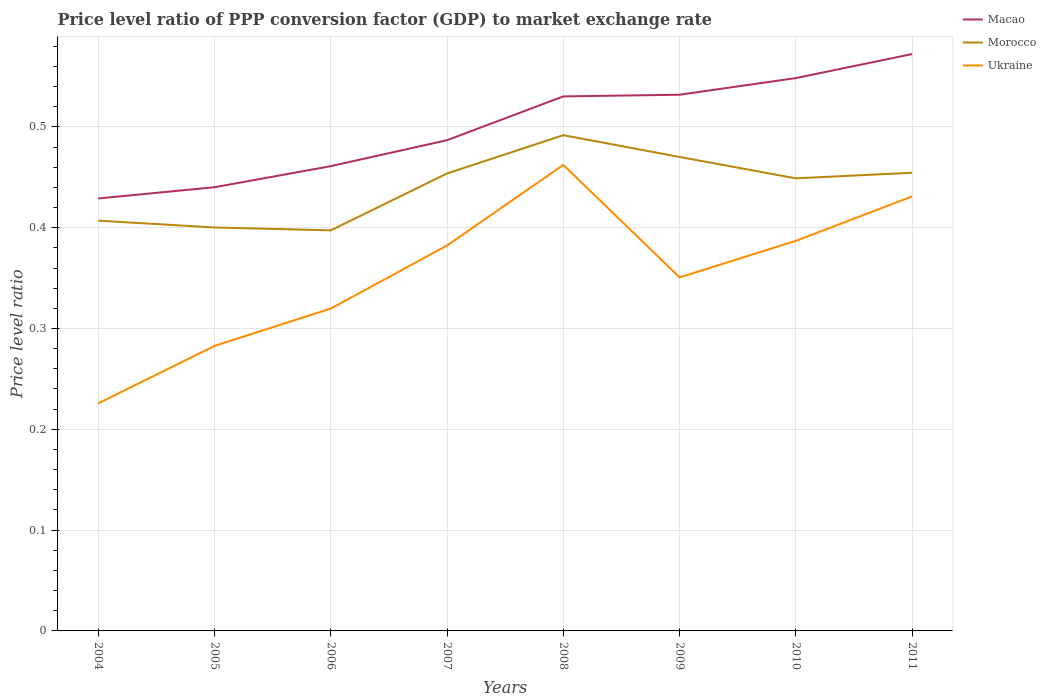How many different coloured lines are there?
Your answer should be very brief. 3. Does the line corresponding to Ukraine intersect with the line corresponding to Morocco?
Offer a very short reply. No. Across all years, what is the maximum price level ratio in Macao?
Give a very brief answer. 0.43. What is the total price level ratio in Morocco in the graph?
Give a very brief answer. -0.06. What is the difference between the highest and the second highest price level ratio in Macao?
Offer a very short reply. 0.14. Is the price level ratio in Ukraine strictly greater than the price level ratio in Morocco over the years?
Keep it short and to the point. Yes. How many lines are there?
Make the answer very short. 3. Does the graph contain any zero values?
Ensure brevity in your answer.  No. Does the graph contain grids?
Provide a short and direct response. Yes. How are the legend labels stacked?
Offer a terse response. Vertical. What is the title of the graph?
Ensure brevity in your answer.  Price level ratio of PPP conversion factor (GDP) to market exchange rate. What is the label or title of the X-axis?
Provide a short and direct response. Years. What is the label or title of the Y-axis?
Make the answer very short. Price level ratio. What is the Price level ratio in Macao in 2004?
Keep it short and to the point. 0.43. What is the Price level ratio in Morocco in 2004?
Your response must be concise. 0.41. What is the Price level ratio of Ukraine in 2004?
Provide a succinct answer. 0.23. What is the Price level ratio in Macao in 2005?
Offer a terse response. 0.44. What is the Price level ratio of Morocco in 2005?
Ensure brevity in your answer.  0.4. What is the Price level ratio of Ukraine in 2005?
Provide a succinct answer. 0.28. What is the Price level ratio in Macao in 2006?
Make the answer very short. 0.46. What is the Price level ratio of Morocco in 2006?
Provide a succinct answer. 0.4. What is the Price level ratio in Ukraine in 2006?
Give a very brief answer. 0.32. What is the Price level ratio in Macao in 2007?
Give a very brief answer. 0.49. What is the Price level ratio of Morocco in 2007?
Make the answer very short. 0.45. What is the Price level ratio in Ukraine in 2007?
Offer a very short reply. 0.38. What is the Price level ratio in Macao in 2008?
Give a very brief answer. 0.53. What is the Price level ratio of Morocco in 2008?
Your answer should be compact. 0.49. What is the Price level ratio of Ukraine in 2008?
Provide a short and direct response. 0.46. What is the Price level ratio in Macao in 2009?
Provide a succinct answer. 0.53. What is the Price level ratio of Morocco in 2009?
Provide a succinct answer. 0.47. What is the Price level ratio of Ukraine in 2009?
Make the answer very short. 0.35. What is the Price level ratio of Macao in 2010?
Your answer should be very brief. 0.55. What is the Price level ratio of Morocco in 2010?
Your answer should be compact. 0.45. What is the Price level ratio of Ukraine in 2010?
Your answer should be very brief. 0.39. What is the Price level ratio of Macao in 2011?
Your answer should be very brief. 0.57. What is the Price level ratio in Morocco in 2011?
Provide a succinct answer. 0.45. What is the Price level ratio of Ukraine in 2011?
Your answer should be compact. 0.43. Across all years, what is the maximum Price level ratio in Macao?
Give a very brief answer. 0.57. Across all years, what is the maximum Price level ratio in Morocco?
Provide a short and direct response. 0.49. Across all years, what is the maximum Price level ratio of Ukraine?
Make the answer very short. 0.46. Across all years, what is the minimum Price level ratio of Macao?
Your answer should be compact. 0.43. Across all years, what is the minimum Price level ratio of Morocco?
Give a very brief answer. 0.4. Across all years, what is the minimum Price level ratio of Ukraine?
Give a very brief answer. 0.23. What is the total Price level ratio of Macao in the graph?
Your answer should be compact. 4. What is the total Price level ratio of Morocco in the graph?
Offer a terse response. 3.52. What is the total Price level ratio of Ukraine in the graph?
Provide a succinct answer. 2.84. What is the difference between the Price level ratio in Macao in 2004 and that in 2005?
Your answer should be compact. -0.01. What is the difference between the Price level ratio in Morocco in 2004 and that in 2005?
Your response must be concise. 0.01. What is the difference between the Price level ratio in Ukraine in 2004 and that in 2005?
Offer a very short reply. -0.06. What is the difference between the Price level ratio in Macao in 2004 and that in 2006?
Ensure brevity in your answer.  -0.03. What is the difference between the Price level ratio of Morocco in 2004 and that in 2006?
Offer a terse response. 0.01. What is the difference between the Price level ratio in Ukraine in 2004 and that in 2006?
Make the answer very short. -0.09. What is the difference between the Price level ratio in Macao in 2004 and that in 2007?
Make the answer very short. -0.06. What is the difference between the Price level ratio in Morocco in 2004 and that in 2007?
Provide a short and direct response. -0.05. What is the difference between the Price level ratio of Ukraine in 2004 and that in 2007?
Your answer should be compact. -0.16. What is the difference between the Price level ratio in Macao in 2004 and that in 2008?
Offer a very short reply. -0.1. What is the difference between the Price level ratio of Morocco in 2004 and that in 2008?
Give a very brief answer. -0.08. What is the difference between the Price level ratio of Ukraine in 2004 and that in 2008?
Offer a terse response. -0.24. What is the difference between the Price level ratio of Macao in 2004 and that in 2009?
Give a very brief answer. -0.1. What is the difference between the Price level ratio of Morocco in 2004 and that in 2009?
Your answer should be very brief. -0.06. What is the difference between the Price level ratio of Ukraine in 2004 and that in 2009?
Keep it short and to the point. -0.12. What is the difference between the Price level ratio in Macao in 2004 and that in 2010?
Keep it short and to the point. -0.12. What is the difference between the Price level ratio of Morocco in 2004 and that in 2010?
Your answer should be very brief. -0.04. What is the difference between the Price level ratio in Ukraine in 2004 and that in 2010?
Provide a short and direct response. -0.16. What is the difference between the Price level ratio of Macao in 2004 and that in 2011?
Provide a short and direct response. -0.14. What is the difference between the Price level ratio of Morocco in 2004 and that in 2011?
Provide a succinct answer. -0.05. What is the difference between the Price level ratio of Ukraine in 2004 and that in 2011?
Provide a succinct answer. -0.21. What is the difference between the Price level ratio in Macao in 2005 and that in 2006?
Offer a terse response. -0.02. What is the difference between the Price level ratio of Morocco in 2005 and that in 2006?
Keep it short and to the point. 0. What is the difference between the Price level ratio in Ukraine in 2005 and that in 2006?
Make the answer very short. -0.04. What is the difference between the Price level ratio in Macao in 2005 and that in 2007?
Offer a terse response. -0.05. What is the difference between the Price level ratio of Morocco in 2005 and that in 2007?
Provide a short and direct response. -0.05. What is the difference between the Price level ratio in Ukraine in 2005 and that in 2007?
Provide a succinct answer. -0.1. What is the difference between the Price level ratio of Macao in 2005 and that in 2008?
Offer a terse response. -0.09. What is the difference between the Price level ratio of Morocco in 2005 and that in 2008?
Your answer should be compact. -0.09. What is the difference between the Price level ratio of Ukraine in 2005 and that in 2008?
Provide a short and direct response. -0.18. What is the difference between the Price level ratio of Macao in 2005 and that in 2009?
Provide a succinct answer. -0.09. What is the difference between the Price level ratio of Morocco in 2005 and that in 2009?
Your response must be concise. -0.07. What is the difference between the Price level ratio in Ukraine in 2005 and that in 2009?
Your answer should be compact. -0.07. What is the difference between the Price level ratio in Macao in 2005 and that in 2010?
Provide a short and direct response. -0.11. What is the difference between the Price level ratio of Morocco in 2005 and that in 2010?
Your answer should be very brief. -0.05. What is the difference between the Price level ratio of Ukraine in 2005 and that in 2010?
Give a very brief answer. -0.1. What is the difference between the Price level ratio of Macao in 2005 and that in 2011?
Offer a very short reply. -0.13. What is the difference between the Price level ratio in Morocco in 2005 and that in 2011?
Your answer should be compact. -0.05. What is the difference between the Price level ratio in Ukraine in 2005 and that in 2011?
Ensure brevity in your answer.  -0.15. What is the difference between the Price level ratio of Macao in 2006 and that in 2007?
Ensure brevity in your answer.  -0.03. What is the difference between the Price level ratio in Morocco in 2006 and that in 2007?
Ensure brevity in your answer.  -0.06. What is the difference between the Price level ratio of Ukraine in 2006 and that in 2007?
Provide a succinct answer. -0.06. What is the difference between the Price level ratio in Macao in 2006 and that in 2008?
Keep it short and to the point. -0.07. What is the difference between the Price level ratio of Morocco in 2006 and that in 2008?
Provide a short and direct response. -0.09. What is the difference between the Price level ratio of Ukraine in 2006 and that in 2008?
Offer a terse response. -0.14. What is the difference between the Price level ratio of Macao in 2006 and that in 2009?
Your answer should be compact. -0.07. What is the difference between the Price level ratio of Morocco in 2006 and that in 2009?
Offer a very short reply. -0.07. What is the difference between the Price level ratio in Ukraine in 2006 and that in 2009?
Keep it short and to the point. -0.03. What is the difference between the Price level ratio in Macao in 2006 and that in 2010?
Your answer should be very brief. -0.09. What is the difference between the Price level ratio in Morocco in 2006 and that in 2010?
Provide a succinct answer. -0.05. What is the difference between the Price level ratio of Ukraine in 2006 and that in 2010?
Ensure brevity in your answer.  -0.07. What is the difference between the Price level ratio of Macao in 2006 and that in 2011?
Provide a short and direct response. -0.11. What is the difference between the Price level ratio in Morocco in 2006 and that in 2011?
Your answer should be compact. -0.06. What is the difference between the Price level ratio of Ukraine in 2006 and that in 2011?
Offer a terse response. -0.11. What is the difference between the Price level ratio in Macao in 2007 and that in 2008?
Provide a short and direct response. -0.04. What is the difference between the Price level ratio in Morocco in 2007 and that in 2008?
Keep it short and to the point. -0.04. What is the difference between the Price level ratio of Ukraine in 2007 and that in 2008?
Make the answer very short. -0.08. What is the difference between the Price level ratio in Macao in 2007 and that in 2009?
Your answer should be compact. -0.05. What is the difference between the Price level ratio of Morocco in 2007 and that in 2009?
Your response must be concise. -0.02. What is the difference between the Price level ratio in Ukraine in 2007 and that in 2009?
Give a very brief answer. 0.03. What is the difference between the Price level ratio in Macao in 2007 and that in 2010?
Provide a short and direct response. -0.06. What is the difference between the Price level ratio in Morocco in 2007 and that in 2010?
Keep it short and to the point. 0. What is the difference between the Price level ratio of Ukraine in 2007 and that in 2010?
Ensure brevity in your answer.  -0. What is the difference between the Price level ratio of Macao in 2007 and that in 2011?
Provide a short and direct response. -0.09. What is the difference between the Price level ratio in Morocco in 2007 and that in 2011?
Offer a terse response. -0. What is the difference between the Price level ratio of Ukraine in 2007 and that in 2011?
Give a very brief answer. -0.05. What is the difference between the Price level ratio in Macao in 2008 and that in 2009?
Ensure brevity in your answer.  -0. What is the difference between the Price level ratio in Morocco in 2008 and that in 2009?
Give a very brief answer. 0.02. What is the difference between the Price level ratio in Ukraine in 2008 and that in 2009?
Your response must be concise. 0.11. What is the difference between the Price level ratio of Macao in 2008 and that in 2010?
Make the answer very short. -0.02. What is the difference between the Price level ratio of Morocco in 2008 and that in 2010?
Ensure brevity in your answer.  0.04. What is the difference between the Price level ratio of Ukraine in 2008 and that in 2010?
Give a very brief answer. 0.08. What is the difference between the Price level ratio in Macao in 2008 and that in 2011?
Your response must be concise. -0.04. What is the difference between the Price level ratio of Morocco in 2008 and that in 2011?
Offer a very short reply. 0.04. What is the difference between the Price level ratio in Ukraine in 2008 and that in 2011?
Offer a terse response. 0.03. What is the difference between the Price level ratio of Macao in 2009 and that in 2010?
Your response must be concise. -0.02. What is the difference between the Price level ratio of Morocco in 2009 and that in 2010?
Provide a short and direct response. 0.02. What is the difference between the Price level ratio of Ukraine in 2009 and that in 2010?
Make the answer very short. -0.04. What is the difference between the Price level ratio in Macao in 2009 and that in 2011?
Ensure brevity in your answer.  -0.04. What is the difference between the Price level ratio of Morocco in 2009 and that in 2011?
Make the answer very short. 0.02. What is the difference between the Price level ratio in Ukraine in 2009 and that in 2011?
Your response must be concise. -0.08. What is the difference between the Price level ratio of Macao in 2010 and that in 2011?
Provide a succinct answer. -0.02. What is the difference between the Price level ratio in Morocco in 2010 and that in 2011?
Your response must be concise. -0.01. What is the difference between the Price level ratio in Ukraine in 2010 and that in 2011?
Your answer should be very brief. -0.04. What is the difference between the Price level ratio in Macao in 2004 and the Price level ratio in Morocco in 2005?
Ensure brevity in your answer.  0.03. What is the difference between the Price level ratio of Macao in 2004 and the Price level ratio of Ukraine in 2005?
Ensure brevity in your answer.  0.15. What is the difference between the Price level ratio of Morocco in 2004 and the Price level ratio of Ukraine in 2005?
Provide a short and direct response. 0.12. What is the difference between the Price level ratio of Macao in 2004 and the Price level ratio of Morocco in 2006?
Your answer should be very brief. 0.03. What is the difference between the Price level ratio in Macao in 2004 and the Price level ratio in Ukraine in 2006?
Your answer should be compact. 0.11. What is the difference between the Price level ratio of Morocco in 2004 and the Price level ratio of Ukraine in 2006?
Provide a short and direct response. 0.09. What is the difference between the Price level ratio of Macao in 2004 and the Price level ratio of Morocco in 2007?
Provide a short and direct response. -0.02. What is the difference between the Price level ratio of Macao in 2004 and the Price level ratio of Ukraine in 2007?
Provide a short and direct response. 0.05. What is the difference between the Price level ratio in Morocco in 2004 and the Price level ratio in Ukraine in 2007?
Provide a succinct answer. 0.02. What is the difference between the Price level ratio of Macao in 2004 and the Price level ratio of Morocco in 2008?
Your answer should be compact. -0.06. What is the difference between the Price level ratio of Macao in 2004 and the Price level ratio of Ukraine in 2008?
Your response must be concise. -0.03. What is the difference between the Price level ratio of Morocco in 2004 and the Price level ratio of Ukraine in 2008?
Offer a very short reply. -0.06. What is the difference between the Price level ratio of Macao in 2004 and the Price level ratio of Morocco in 2009?
Provide a short and direct response. -0.04. What is the difference between the Price level ratio in Macao in 2004 and the Price level ratio in Ukraine in 2009?
Keep it short and to the point. 0.08. What is the difference between the Price level ratio in Morocco in 2004 and the Price level ratio in Ukraine in 2009?
Keep it short and to the point. 0.06. What is the difference between the Price level ratio in Macao in 2004 and the Price level ratio in Morocco in 2010?
Give a very brief answer. -0.02. What is the difference between the Price level ratio in Macao in 2004 and the Price level ratio in Ukraine in 2010?
Offer a very short reply. 0.04. What is the difference between the Price level ratio of Macao in 2004 and the Price level ratio of Morocco in 2011?
Your response must be concise. -0.03. What is the difference between the Price level ratio in Macao in 2004 and the Price level ratio in Ukraine in 2011?
Provide a short and direct response. -0. What is the difference between the Price level ratio of Morocco in 2004 and the Price level ratio of Ukraine in 2011?
Keep it short and to the point. -0.02. What is the difference between the Price level ratio in Macao in 2005 and the Price level ratio in Morocco in 2006?
Keep it short and to the point. 0.04. What is the difference between the Price level ratio of Macao in 2005 and the Price level ratio of Ukraine in 2006?
Offer a terse response. 0.12. What is the difference between the Price level ratio in Morocco in 2005 and the Price level ratio in Ukraine in 2006?
Make the answer very short. 0.08. What is the difference between the Price level ratio in Macao in 2005 and the Price level ratio in Morocco in 2007?
Provide a succinct answer. -0.01. What is the difference between the Price level ratio of Macao in 2005 and the Price level ratio of Ukraine in 2007?
Ensure brevity in your answer.  0.06. What is the difference between the Price level ratio in Morocco in 2005 and the Price level ratio in Ukraine in 2007?
Your answer should be compact. 0.02. What is the difference between the Price level ratio in Macao in 2005 and the Price level ratio in Morocco in 2008?
Provide a short and direct response. -0.05. What is the difference between the Price level ratio in Macao in 2005 and the Price level ratio in Ukraine in 2008?
Make the answer very short. -0.02. What is the difference between the Price level ratio in Morocco in 2005 and the Price level ratio in Ukraine in 2008?
Provide a short and direct response. -0.06. What is the difference between the Price level ratio in Macao in 2005 and the Price level ratio in Morocco in 2009?
Keep it short and to the point. -0.03. What is the difference between the Price level ratio in Macao in 2005 and the Price level ratio in Ukraine in 2009?
Provide a succinct answer. 0.09. What is the difference between the Price level ratio of Morocco in 2005 and the Price level ratio of Ukraine in 2009?
Make the answer very short. 0.05. What is the difference between the Price level ratio in Macao in 2005 and the Price level ratio in Morocco in 2010?
Your answer should be compact. -0.01. What is the difference between the Price level ratio in Macao in 2005 and the Price level ratio in Ukraine in 2010?
Provide a succinct answer. 0.05. What is the difference between the Price level ratio in Morocco in 2005 and the Price level ratio in Ukraine in 2010?
Give a very brief answer. 0.01. What is the difference between the Price level ratio of Macao in 2005 and the Price level ratio of Morocco in 2011?
Your answer should be compact. -0.01. What is the difference between the Price level ratio of Macao in 2005 and the Price level ratio of Ukraine in 2011?
Offer a very short reply. 0.01. What is the difference between the Price level ratio in Morocco in 2005 and the Price level ratio in Ukraine in 2011?
Ensure brevity in your answer.  -0.03. What is the difference between the Price level ratio in Macao in 2006 and the Price level ratio in Morocco in 2007?
Offer a terse response. 0.01. What is the difference between the Price level ratio of Macao in 2006 and the Price level ratio of Ukraine in 2007?
Ensure brevity in your answer.  0.08. What is the difference between the Price level ratio of Morocco in 2006 and the Price level ratio of Ukraine in 2007?
Offer a terse response. 0.01. What is the difference between the Price level ratio in Macao in 2006 and the Price level ratio in Morocco in 2008?
Ensure brevity in your answer.  -0.03. What is the difference between the Price level ratio in Macao in 2006 and the Price level ratio in Ukraine in 2008?
Your answer should be very brief. -0. What is the difference between the Price level ratio in Morocco in 2006 and the Price level ratio in Ukraine in 2008?
Ensure brevity in your answer.  -0.06. What is the difference between the Price level ratio in Macao in 2006 and the Price level ratio in Morocco in 2009?
Make the answer very short. -0.01. What is the difference between the Price level ratio in Macao in 2006 and the Price level ratio in Ukraine in 2009?
Your response must be concise. 0.11. What is the difference between the Price level ratio of Morocco in 2006 and the Price level ratio of Ukraine in 2009?
Make the answer very short. 0.05. What is the difference between the Price level ratio in Macao in 2006 and the Price level ratio in Morocco in 2010?
Your response must be concise. 0.01. What is the difference between the Price level ratio of Macao in 2006 and the Price level ratio of Ukraine in 2010?
Your answer should be very brief. 0.07. What is the difference between the Price level ratio in Morocco in 2006 and the Price level ratio in Ukraine in 2010?
Your answer should be compact. 0.01. What is the difference between the Price level ratio in Macao in 2006 and the Price level ratio in Morocco in 2011?
Give a very brief answer. 0.01. What is the difference between the Price level ratio in Macao in 2006 and the Price level ratio in Ukraine in 2011?
Give a very brief answer. 0.03. What is the difference between the Price level ratio of Morocco in 2006 and the Price level ratio of Ukraine in 2011?
Provide a short and direct response. -0.03. What is the difference between the Price level ratio of Macao in 2007 and the Price level ratio of Morocco in 2008?
Your answer should be very brief. -0.01. What is the difference between the Price level ratio of Macao in 2007 and the Price level ratio of Ukraine in 2008?
Ensure brevity in your answer.  0.02. What is the difference between the Price level ratio of Morocco in 2007 and the Price level ratio of Ukraine in 2008?
Make the answer very short. -0.01. What is the difference between the Price level ratio in Macao in 2007 and the Price level ratio in Morocco in 2009?
Make the answer very short. 0.02. What is the difference between the Price level ratio of Macao in 2007 and the Price level ratio of Ukraine in 2009?
Provide a succinct answer. 0.14. What is the difference between the Price level ratio of Morocco in 2007 and the Price level ratio of Ukraine in 2009?
Your answer should be very brief. 0.1. What is the difference between the Price level ratio in Macao in 2007 and the Price level ratio in Morocco in 2010?
Provide a succinct answer. 0.04. What is the difference between the Price level ratio of Macao in 2007 and the Price level ratio of Ukraine in 2010?
Provide a short and direct response. 0.1. What is the difference between the Price level ratio in Morocco in 2007 and the Price level ratio in Ukraine in 2010?
Give a very brief answer. 0.07. What is the difference between the Price level ratio in Macao in 2007 and the Price level ratio in Morocco in 2011?
Provide a succinct answer. 0.03. What is the difference between the Price level ratio in Macao in 2007 and the Price level ratio in Ukraine in 2011?
Ensure brevity in your answer.  0.06. What is the difference between the Price level ratio in Morocco in 2007 and the Price level ratio in Ukraine in 2011?
Your answer should be compact. 0.02. What is the difference between the Price level ratio of Macao in 2008 and the Price level ratio of Morocco in 2009?
Keep it short and to the point. 0.06. What is the difference between the Price level ratio of Macao in 2008 and the Price level ratio of Ukraine in 2009?
Offer a terse response. 0.18. What is the difference between the Price level ratio of Morocco in 2008 and the Price level ratio of Ukraine in 2009?
Provide a short and direct response. 0.14. What is the difference between the Price level ratio of Macao in 2008 and the Price level ratio of Morocco in 2010?
Your response must be concise. 0.08. What is the difference between the Price level ratio of Macao in 2008 and the Price level ratio of Ukraine in 2010?
Provide a succinct answer. 0.14. What is the difference between the Price level ratio in Morocco in 2008 and the Price level ratio in Ukraine in 2010?
Keep it short and to the point. 0.1. What is the difference between the Price level ratio of Macao in 2008 and the Price level ratio of Morocco in 2011?
Provide a short and direct response. 0.08. What is the difference between the Price level ratio of Macao in 2008 and the Price level ratio of Ukraine in 2011?
Offer a very short reply. 0.1. What is the difference between the Price level ratio in Morocco in 2008 and the Price level ratio in Ukraine in 2011?
Your answer should be compact. 0.06. What is the difference between the Price level ratio in Macao in 2009 and the Price level ratio in Morocco in 2010?
Your answer should be very brief. 0.08. What is the difference between the Price level ratio in Macao in 2009 and the Price level ratio in Ukraine in 2010?
Give a very brief answer. 0.14. What is the difference between the Price level ratio of Morocco in 2009 and the Price level ratio of Ukraine in 2010?
Your response must be concise. 0.08. What is the difference between the Price level ratio in Macao in 2009 and the Price level ratio in Morocco in 2011?
Give a very brief answer. 0.08. What is the difference between the Price level ratio in Macao in 2009 and the Price level ratio in Ukraine in 2011?
Your answer should be very brief. 0.1. What is the difference between the Price level ratio of Morocco in 2009 and the Price level ratio of Ukraine in 2011?
Provide a short and direct response. 0.04. What is the difference between the Price level ratio of Macao in 2010 and the Price level ratio of Morocco in 2011?
Your answer should be compact. 0.09. What is the difference between the Price level ratio in Macao in 2010 and the Price level ratio in Ukraine in 2011?
Provide a succinct answer. 0.12. What is the difference between the Price level ratio of Morocco in 2010 and the Price level ratio of Ukraine in 2011?
Keep it short and to the point. 0.02. What is the average Price level ratio of Morocco per year?
Provide a short and direct response. 0.44. What is the average Price level ratio of Ukraine per year?
Make the answer very short. 0.36. In the year 2004, what is the difference between the Price level ratio in Macao and Price level ratio in Morocco?
Your response must be concise. 0.02. In the year 2004, what is the difference between the Price level ratio of Macao and Price level ratio of Ukraine?
Provide a short and direct response. 0.2. In the year 2004, what is the difference between the Price level ratio in Morocco and Price level ratio in Ukraine?
Offer a terse response. 0.18. In the year 2005, what is the difference between the Price level ratio in Macao and Price level ratio in Morocco?
Make the answer very short. 0.04. In the year 2005, what is the difference between the Price level ratio in Macao and Price level ratio in Ukraine?
Keep it short and to the point. 0.16. In the year 2005, what is the difference between the Price level ratio of Morocco and Price level ratio of Ukraine?
Offer a very short reply. 0.12. In the year 2006, what is the difference between the Price level ratio of Macao and Price level ratio of Morocco?
Ensure brevity in your answer.  0.06. In the year 2006, what is the difference between the Price level ratio in Macao and Price level ratio in Ukraine?
Ensure brevity in your answer.  0.14. In the year 2006, what is the difference between the Price level ratio in Morocco and Price level ratio in Ukraine?
Provide a short and direct response. 0.08. In the year 2007, what is the difference between the Price level ratio of Macao and Price level ratio of Morocco?
Your answer should be compact. 0.03. In the year 2007, what is the difference between the Price level ratio of Macao and Price level ratio of Ukraine?
Give a very brief answer. 0.1. In the year 2007, what is the difference between the Price level ratio in Morocco and Price level ratio in Ukraine?
Provide a short and direct response. 0.07. In the year 2008, what is the difference between the Price level ratio in Macao and Price level ratio in Morocco?
Ensure brevity in your answer.  0.04. In the year 2008, what is the difference between the Price level ratio of Macao and Price level ratio of Ukraine?
Offer a very short reply. 0.07. In the year 2008, what is the difference between the Price level ratio of Morocco and Price level ratio of Ukraine?
Keep it short and to the point. 0.03. In the year 2009, what is the difference between the Price level ratio in Macao and Price level ratio in Morocco?
Your response must be concise. 0.06. In the year 2009, what is the difference between the Price level ratio of Macao and Price level ratio of Ukraine?
Ensure brevity in your answer.  0.18. In the year 2009, what is the difference between the Price level ratio in Morocco and Price level ratio in Ukraine?
Your answer should be very brief. 0.12. In the year 2010, what is the difference between the Price level ratio in Macao and Price level ratio in Morocco?
Make the answer very short. 0.1. In the year 2010, what is the difference between the Price level ratio in Macao and Price level ratio in Ukraine?
Provide a short and direct response. 0.16. In the year 2010, what is the difference between the Price level ratio of Morocco and Price level ratio of Ukraine?
Make the answer very short. 0.06. In the year 2011, what is the difference between the Price level ratio in Macao and Price level ratio in Morocco?
Your answer should be compact. 0.12. In the year 2011, what is the difference between the Price level ratio of Macao and Price level ratio of Ukraine?
Your response must be concise. 0.14. In the year 2011, what is the difference between the Price level ratio in Morocco and Price level ratio in Ukraine?
Make the answer very short. 0.02. What is the ratio of the Price level ratio in Macao in 2004 to that in 2005?
Your response must be concise. 0.97. What is the ratio of the Price level ratio of Morocco in 2004 to that in 2005?
Give a very brief answer. 1.02. What is the ratio of the Price level ratio in Ukraine in 2004 to that in 2005?
Provide a succinct answer. 0.8. What is the ratio of the Price level ratio of Macao in 2004 to that in 2006?
Provide a short and direct response. 0.93. What is the ratio of the Price level ratio of Morocco in 2004 to that in 2006?
Provide a succinct answer. 1.02. What is the ratio of the Price level ratio in Ukraine in 2004 to that in 2006?
Offer a very short reply. 0.71. What is the ratio of the Price level ratio in Macao in 2004 to that in 2007?
Make the answer very short. 0.88. What is the ratio of the Price level ratio of Morocco in 2004 to that in 2007?
Make the answer very short. 0.9. What is the ratio of the Price level ratio of Ukraine in 2004 to that in 2007?
Your response must be concise. 0.59. What is the ratio of the Price level ratio in Macao in 2004 to that in 2008?
Keep it short and to the point. 0.81. What is the ratio of the Price level ratio in Morocco in 2004 to that in 2008?
Give a very brief answer. 0.83. What is the ratio of the Price level ratio in Ukraine in 2004 to that in 2008?
Offer a terse response. 0.49. What is the ratio of the Price level ratio of Macao in 2004 to that in 2009?
Make the answer very short. 0.81. What is the ratio of the Price level ratio of Morocco in 2004 to that in 2009?
Provide a succinct answer. 0.87. What is the ratio of the Price level ratio of Ukraine in 2004 to that in 2009?
Give a very brief answer. 0.64. What is the ratio of the Price level ratio of Macao in 2004 to that in 2010?
Provide a short and direct response. 0.78. What is the ratio of the Price level ratio in Morocco in 2004 to that in 2010?
Ensure brevity in your answer.  0.91. What is the ratio of the Price level ratio of Ukraine in 2004 to that in 2010?
Provide a short and direct response. 0.58. What is the ratio of the Price level ratio in Macao in 2004 to that in 2011?
Your answer should be compact. 0.75. What is the ratio of the Price level ratio of Morocco in 2004 to that in 2011?
Offer a very short reply. 0.9. What is the ratio of the Price level ratio in Ukraine in 2004 to that in 2011?
Offer a very short reply. 0.52. What is the ratio of the Price level ratio in Macao in 2005 to that in 2006?
Provide a short and direct response. 0.95. What is the ratio of the Price level ratio in Morocco in 2005 to that in 2006?
Your response must be concise. 1.01. What is the ratio of the Price level ratio in Ukraine in 2005 to that in 2006?
Your response must be concise. 0.88. What is the ratio of the Price level ratio of Macao in 2005 to that in 2007?
Keep it short and to the point. 0.9. What is the ratio of the Price level ratio in Morocco in 2005 to that in 2007?
Provide a succinct answer. 0.88. What is the ratio of the Price level ratio in Ukraine in 2005 to that in 2007?
Give a very brief answer. 0.74. What is the ratio of the Price level ratio in Macao in 2005 to that in 2008?
Give a very brief answer. 0.83. What is the ratio of the Price level ratio of Morocco in 2005 to that in 2008?
Make the answer very short. 0.81. What is the ratio of the Price level ratio of Ukraine in 2005 to that in 2008?
Your answer should be very brief. 0.61. What is the ratio of the Price level ratio of Macao in 2005 to that in 2009?
Offer a very short reply. 0.83. What is the ratio of the Price level ratio of Morocco in 2005 to that in 2009?
Offer a terse response. 0.85. What is the ratio of the Price level ratio in Ukraine in 2005 to that in 2009?
Provide a succinct answer. 0.81. What is the ratio of the Price level ratio of Macao in 2005 to that in 2010?
Ensure brevity in your answer.  0.8. What is the ratio of the Price level ratio in Morocco in 2005 to that in 2010?
Provide a succinct answer. 0.89. What is the ratio of the Price level ratio in Ukraine in 2005 to that in 2010?
Ensure brevity in your answer.  0.73. What is the ratio of the Price level ratio in Macao in 2005 to that in 2011?
Give a very brief answer. 0.77. What is the ratio of the Price level ratio of Morocco in 2005 to that in 2011?
Offer a terse response. 0.88. What is the ratio of the Price level ratio of Ukraine in 2005 to that in 2011?
Provide a succinct answer. 0.66. What is the ratio of the Price level ratio of Macao in 2006 to that in 2007?
Make the answer very short. 0.95. What is the ratio of the Price level ratio of Morocco in 2006 to that in 2007?
Provide a succinct answer. 0.88. What is the ratio of the Price level ratio in Ukraine in 2006 to that in 2007?
Your answer should be compact. 0.84. What is the ratio of the Price level ratio in Macao in 2006 to that in 2008?
Your response must be concise. 0.87. What is the ratio of the Price level ratio in Morocco in 2006 to that in 2008?
Ensure brevity in your answer.  0.81. What is the ratio of the Price level ratio of Ukraine in 2006 to that in 2008?
Offer a terse response. 0.69. What is the ratio of the Price level ratio in Macao in 2006 to that in 2009?
Provide a succinct answer. 0.87. What is the ratio of the Price level ratio in Morocco in 2006 to that in 2009?
Your answer should be very brief. 0.85. What is the ratio of the Price level ratio in Ukraine in 2006 to that in 2009?
Provide a short and direct response. 0.91. What is the ratio of the Price level ratio in Macao in 2006 to that in 2010?
Your answer should be compact. 0.84. What is the ratio of the Price level ratio of Morocco in 2006 to that in 2010?
Keep it short and to the point. 0.89. What is the ratio of the Price level ratio of Ukraine in 2006 to that in 2010?
Keep it short and to the point. 0.83. What is the ratio of the Price level ratio of Macao in 2006 to that in 2011?
Offer a terse response. 0.81. What is the ratio of the Price level ratio of Morocco in 2006 to that in 2011?
Your response must be concise. 0.87. What is the ratio of the Price level ratio in Ukraine in 2006 to that in 2011?
Make the answer very short. 0.74. What is the ratio of the Price level ratio in Macao in 2007 to that in 2008?
Offer a terse response. 0.92. What is the ratio of the Price level ratio in Morocco in 2007 to that in 2008?
Your response must be concise. 0.92. What is the ratio of the Price level ratio in Ukraine in 2007 to that in 2008?
Offer a terse response. 0.83. What is the ratio of the Price level ratio of Macao in 2007 to that in 2009?
Ensure brevity in your answer.  0.92. What is the ratio of the Price level ratio in Morocco in 2007 to that in 2009?
Offer a terse response. 0.97. What is the ratio of the Price level ratio in Ukraine in 2007 to that in 2009?
Provide a succinct answer. 1.09. What is the ratio of the Price level ratio in Macao in 2007 to that in 2010?
Your answer should be compact. 0.89. What is the ratio of the Price level ratio of Morocco in 2007 to that in 2010?
Ensure brevity in your answer.  1.01. What is the ratio of the Price level ratio in Macao in 2007 to that in 2011?
Keep it short and to the point. 0.85. What is the ratio of the Price level ratio of Ukraine in 2007 to that in 2011?
Offer a terse response. 0.89. What is the ratio of the Price level ratio in Macao in 2008 to that in 2009?
Your response must be concise. 1. What is the ratio of the Price level ratio in Morocco in 2008 to that in 2009?
Offer a very short reply. 1.05. What is the ratio of the Price level ratio of Ukraine in 2008 to that in 2009?
Provide a succinct answer. 1.32. What is the ratio of the Price level ratio in Macao in 2008 to that in 2010?
Your answer should be compact. 0.97. What is the ratio of the Price level ratio in Morocco in 2008 to that in 2010?
Your response must be concise. 1.1. What is the ratio of the Price level ratio of Ukraine in 2008 to that in 2010?
Give a very brief answer. 1.19. What is the ratio of the Price level ratio in Macao in 2008 to that in 2011?
Your answer should be compact. 0.93. What is the ratio of the Price level ratio in Morocco in 2008 to that in 2011?
Provide a succinct answer. 1.08. What is the ratio of the Price level ratio in Ukraine in 2008 to that in 2011?
Offer a very short reply. 1.07. What is the ratio of the Price level ratio of Macao in 2009 to that in 2010?
Your answer should be very brief. 0.97. What is the ratio of the Price level ratio of Morocco in 2009 to that in 2010?
Make the answer very short. 1.05. What is the ratio of the Price level ratio in Ukraine in 2009 to that in 2010?
Your answer should be very brief. 0.91. What is the ratio of the Price level ratio of Macao in 2009 to that in 2011?
Keep it short and to the point. 0.93. What is the ratio of the Price level ratio of Morocco in 2009 to that in 2011?
Provide a succinct answer. 1.03. What is the ratio of the Price level ratio of Ukraine in 2009 to that in 2011?
Offer a very short reply. 0.81. What is the ratio of the Price level ratio of Morocco in 2010 to that in 2011?
Offer a terse response. 0.99. What is the ratio of the Price level ratio in Ukraine in 2010 to that in 2011?
Offer a very short reply. 0.9. What is the difference between the highest and the second highest Price level ratio of Macao?
Make the answer very short. 0.02. What is the difference between the highest and the second highest Price level ratio of Morocco?
Offer a very short reply. 0.02. What is the difference between the highest and the second highest Price level ratio in Ukraine?
Provide a short and direct response. 0.03. What is the difference between the highest and the lowest Price level ratio of Macao?
Your response must be concise. 0.14. What is the difference between the highest and the lowest Price level ratio of Morocco?
Your answer should be very brief. 0.09. What is the difference between the highest and the lowest Price level ratio in Ukraine?
Provide a succinct answer. 0.24. 